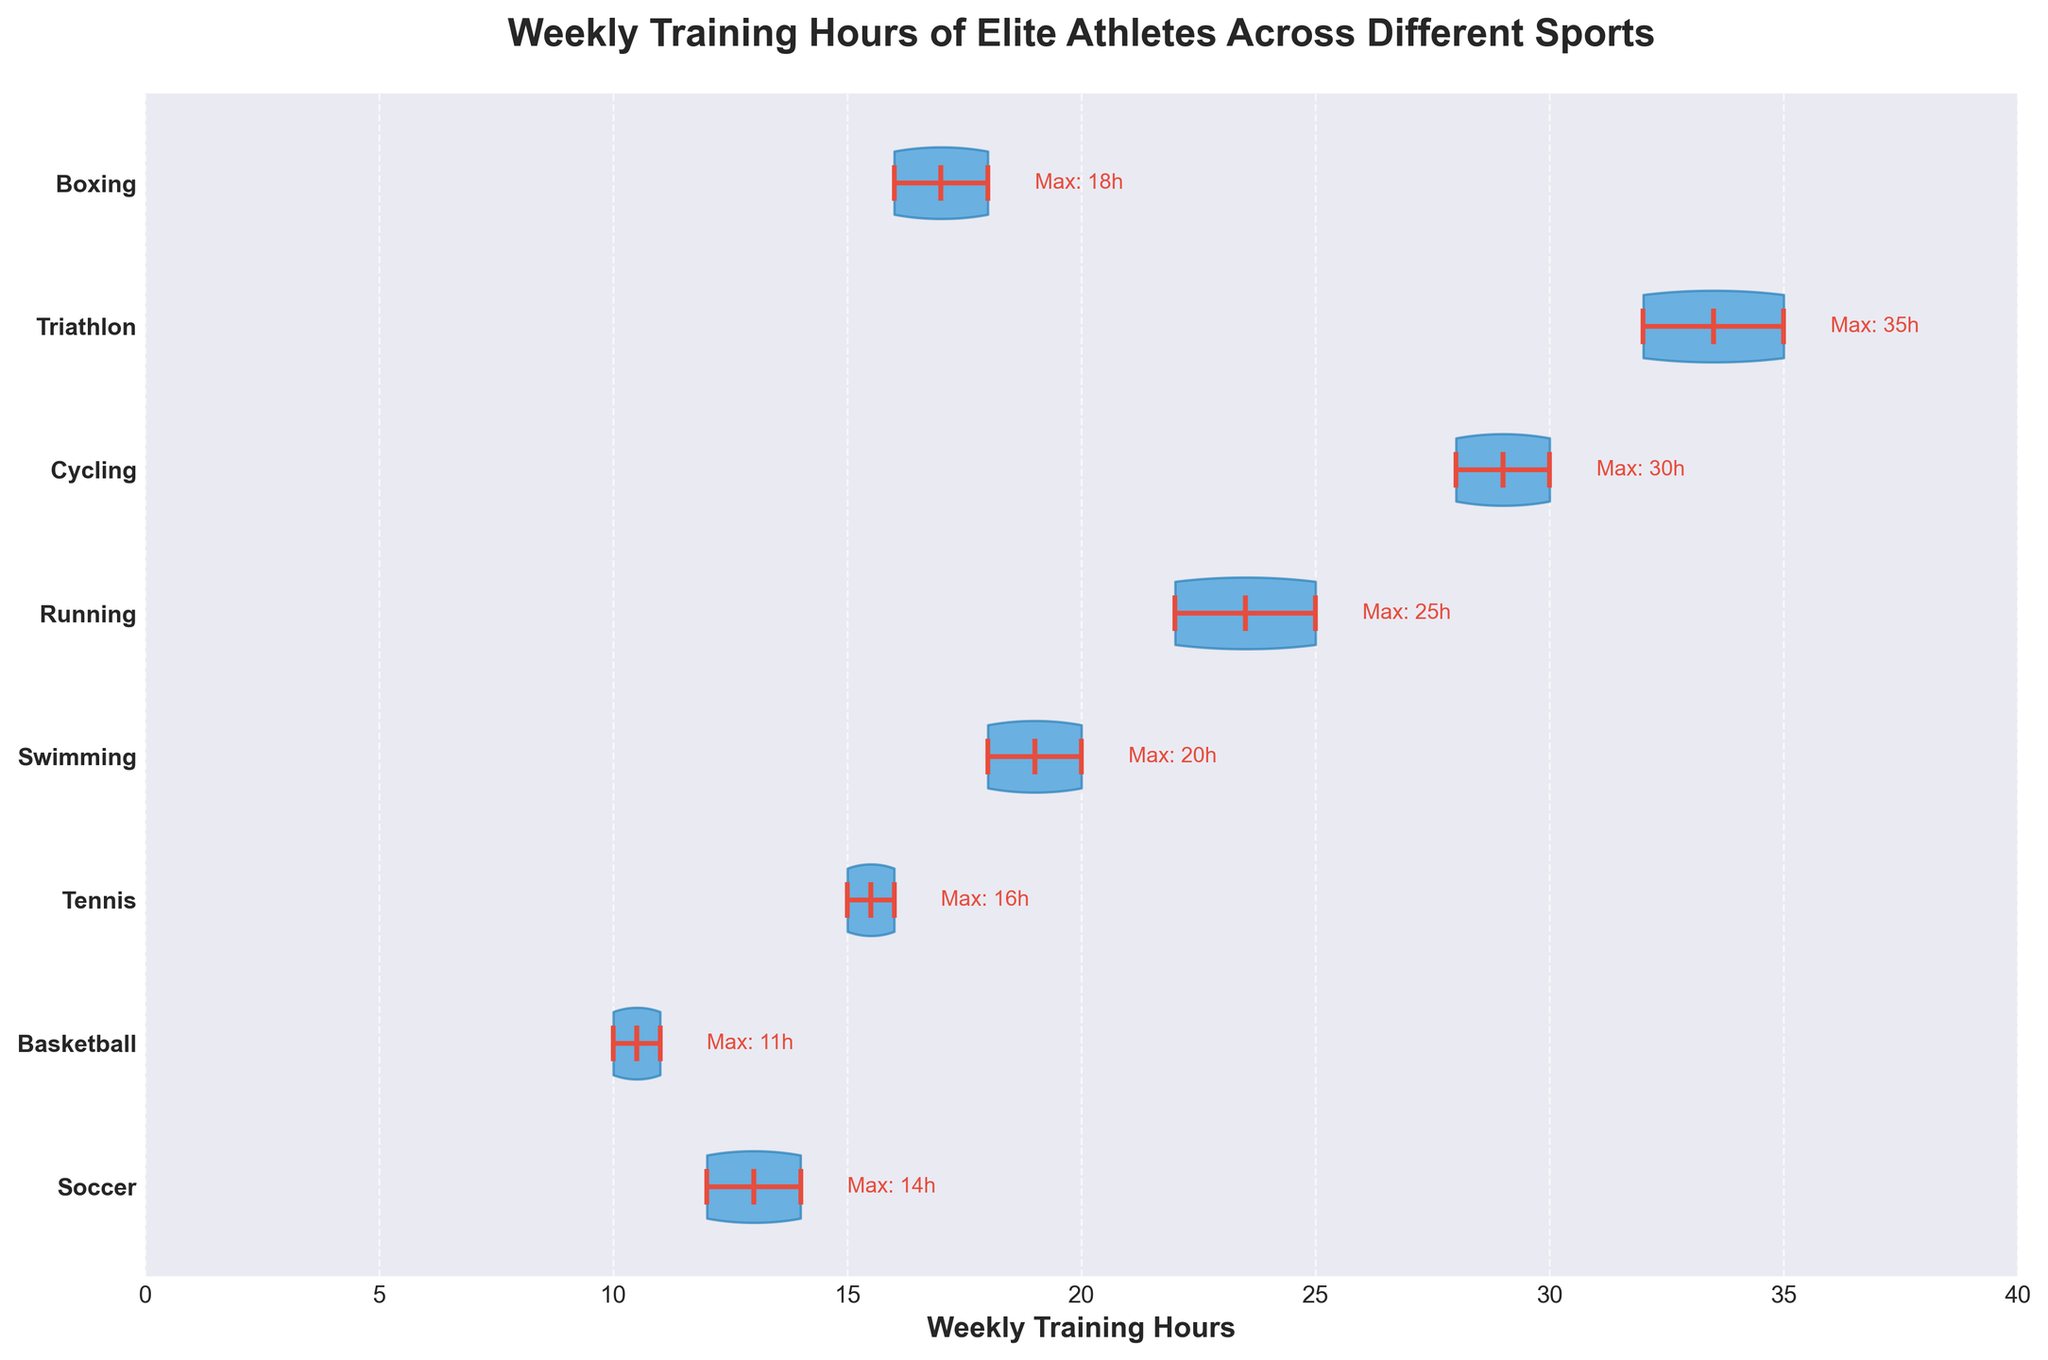What is the title of the chart? The title is typically located at the top of the figure and clearly labeled. It summarizes the purpose of the chart.
Answer: Weekly Training Hours of Elite Athletes Across Different Sports What do the horizontal axis and vertical axis represent? The horizontal axis typically represents the metric of interest, while the vertical axis often represents the categories. In this case, the horizontal axis labels 'Weekly Training Hours' and the vertical axis lists different sports.
Answer: Horizontal axis: Weekly Training Hours, Vertical axis: Different Sports Which sport has the highest maximum weekly training hours? To identify this, look for the maximum value labeled on the right side of each violin plot. The sport with the highest number will have the maximum weekly training hours.
Answer: Triathlon Which sport has the least variance in weekly training hours among its athletes? To determine this, look at the width of the violin plots. The narrower the plot, the less variance there is in the training hours. The thinnest plot will indicate the least variance.
Answer: Basketball What is the median weekly training hours for swimming? The median is shown as a line within the violin plot. Locate the median line within the swimming plot for the value.
Answer: 19 hours How many sports have a median weekly training hours of 16 hours or more? Examine the violin plots for each sport and identify the median lines. Count the number of sports where the median line is at or above 16.
Answer: 5 sports Compare the average training hours for soccer and running. Which one is greater? To find the average, look at the mean markers in the plots (typically represented by a dot). Compare the mean of soccer to the mean of running.
Answer: Running has greater average training hours What is the range of weekly training hours for the sport of cycling? The range is calculated by subtracting the minimum value from the maximum value within the violin plot. Check the extremum points of the cycling plot for these values.
Answer: 28 to 30 hours Which sport has more variation in training hours, tennis or boxing? Consider the spread and width of the two corresponding violin plots. The sport with a wider plot has more variation.
Answer: Tennis What is the significance of the different line colors in the violin plots? The different line colors generally represent various components of the data, such as the mean, median, and extrema.
Answer: Mean, Median, and Extrema 